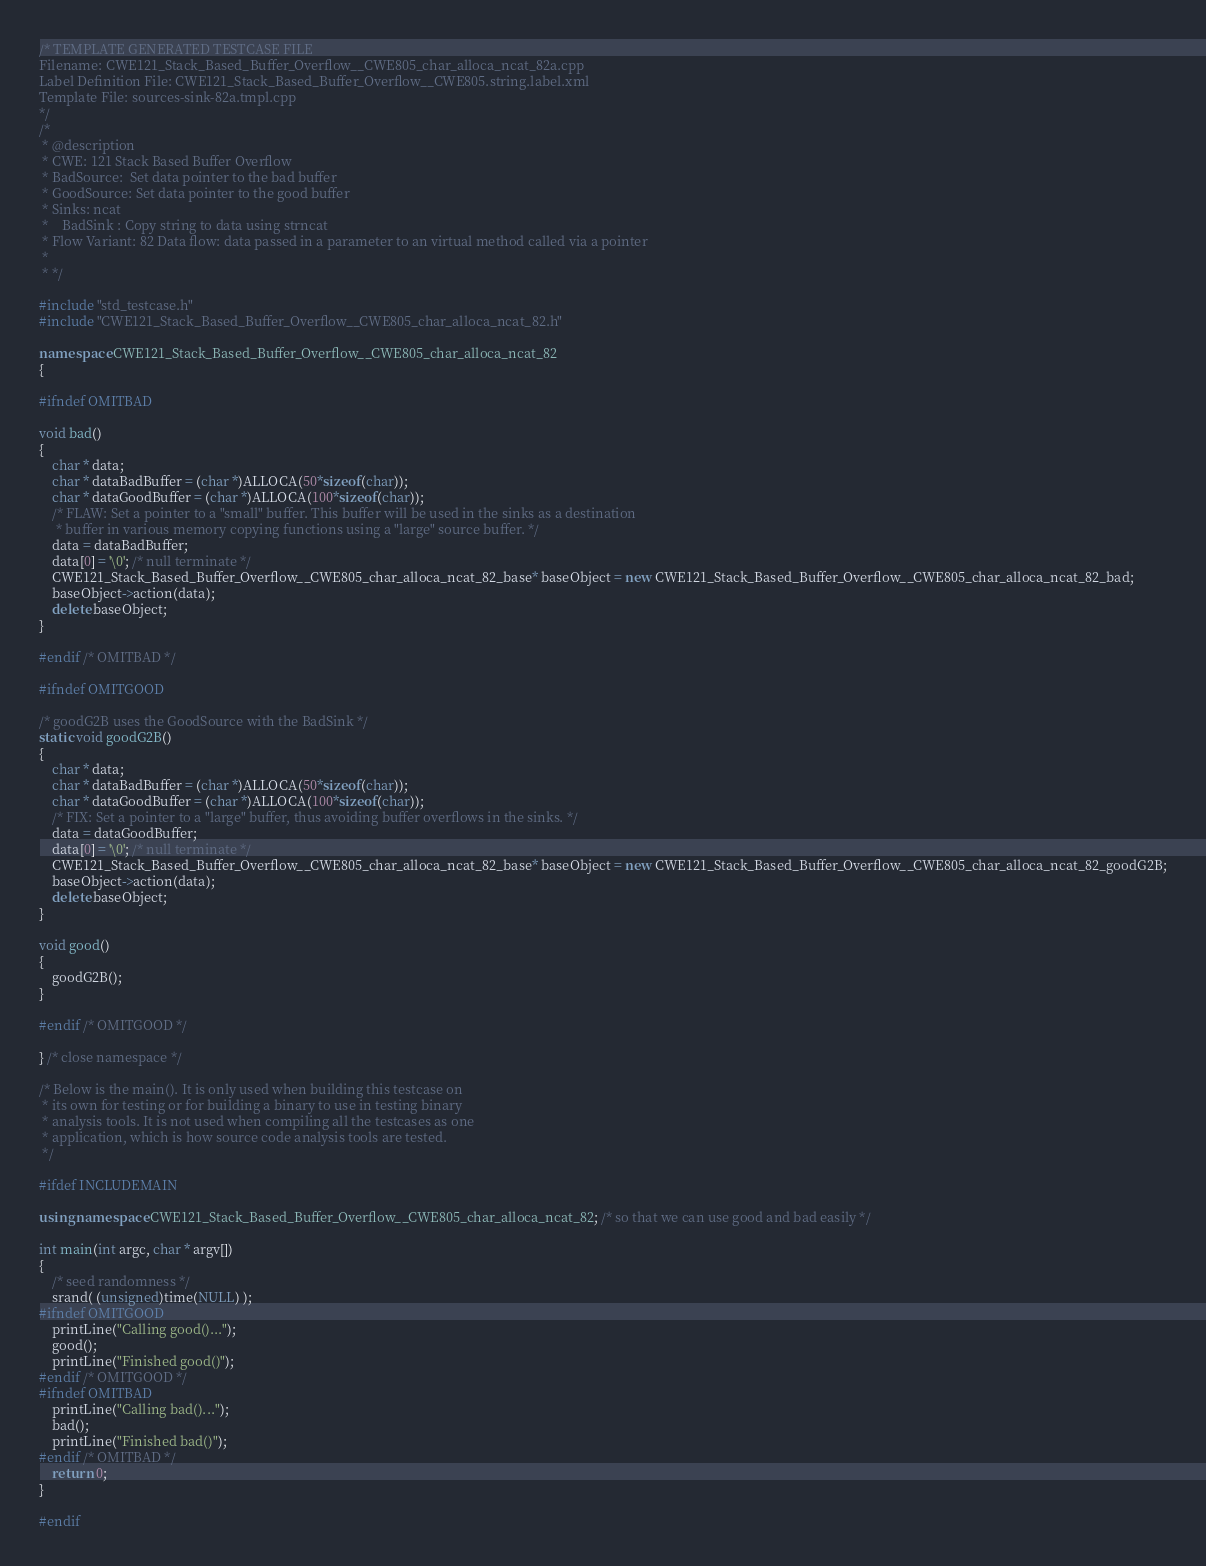<code> <loc_0><loc_0><loc_500><loc_500><_C++_>/* TEMPLATE GENERATED TESTCASE FILE
Filename: CWE121_Stack_Based_Buffer_Overflow__CWE805_char_alloca_ncat_82a.cpp
Label Definition File: CWE121_Stack_Based_Buffer_Overflow__CWE805.string.label.xml
Template File: sources-sink-82a.tmpl.cpp
*/
/*
 * @description
 * CWE: 121 Stack Based Buffer Overflow
 * BadSource:  Set data pointer to the bad buffer
 * GoodSource: Set data pointer to the good buffer
 * Sinks: ncat
 *    BadSink : Copy string to data using strncat
 * Flow Variant: 82 Data flow: data passed in a parameter to an virtual method called via a pointer
 *
 * */

#include "std_testcase.h"
#include "CWE121_Stack_Based_Buffer_Overflow__CWE805_char_alloca_ncat_82.h"

namespace CWE121_Stack_Based_Buffer_Overflow__CWE805_char_alloca_ncat_82
{

#ifndef OMITBAD

void bad()
{
    char * data;
    char * dataBadBuffer = (char *)ALLOCA(50*sizeof(char));
    char * dataGoodBuffer = (char *)ALLOCA(100*sizeof(char));
    /* FLAW: Set a pointer to a "small" buffer. This buffer will be used in the sinks as a destination
     * buffer in various memory copying functions using a "large" source buffer. */
    data = dataBadBuffer;
    data[0] = '\0'; /* null terminate */
    CWE121_Stack_Based_Buffer_Overflow__CWE805_char_alloca_ncat_82_base* baseObject = new CWE121_Stack_Based_Buffer_Overflow__CWE805_char_alloca_ncat_82_bad;
    baseObject->action(data);
    delete baseObject;
}

#endif /* OMITBAD */

#ifndef OMITGOOD

/* goodG2B uses the GoodSource with the BadSink */
static void goodG2B()
{
    char * data;
    char * dataBadBuffer = (char *)ALLOCA(50*sizeof(char));
    char * dataGoodBuffer = (char *)ALLOCA(100*sizeof(char));
    /* FIX: Set a pointer to a "large" buffer, thus avoiding buffer overflows in the sinks. */
    data = dataGoodBuffer;
    data[0] = '\0'; /* null terminate */
    CWE121_Stack_Based_Buffer_Overflow__CWE805_char_alloca_ncat_82_base* baseObject = new CWE121_Stack_Based_Buffer_Overflow__CWE805_char_alloca_ncat_82_goodG2B;
    baseObject->action(data);
    delete baseObject;
}

void good()
{
    goodG2B();
}

#endif /* OMITGOOD */

} /* close namespace */

/* Below is the main(). It is only used when building this testcase on
 * its own for testing or for building a binary to use in testing binary
 * analysis tools. It is not used when compiling all the testcases as one
 * application, which is how source code analysis tools are tested.
 */

#ifdef INCLUDEMAIN

using namespace CWE121_Stack_Based_Buffer_Overflow__CWE805_char_alloca_ncat_82; /* so that we can use good and bad easily */

int main(int argc, char * argv[])
{
    /* seed randomness */
    srand( (unsigned)time(NULL) );
#ifndef OMITGOOD
    printLine("Calling good()...");
    good();
    printLine("Finished good()");
#endif /* OMITGOOD */
#ifndef OMITBAD
    printLine("Calling bad()...");
    bad();
    printLine("Finished bad()");
#endif /* OMITBAD */
    return 0;
}

#endif
</code> 